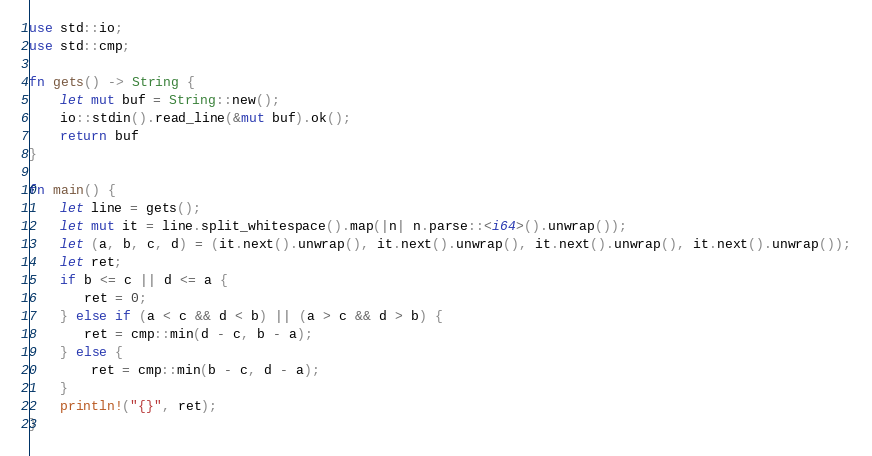<code> <loc_0><loc_0><loc_500><loc_500><_Rust_>use std::io;
use std::cmp;

fn gets() -> String {
    let mut buf = String::new();
    io::stdin().read_line(&mut buf).ok();
    return buf
}

fn main() {
    let line = gets();
    let mut it = line.split_whitespace().map(|n| n.parse::<i64>().unwrap());
    let (a, b, c, d) = (it.next().unwrap(), it.next().unwrap(), it.next().unwrap(), it.next().unwrap());
    let ret;
    if b <= c || d <= a {
       ret = 0;
    } else if (a < c && d < b) || (a > c && d > b) {
       ret = cmp::min(d - c, b - a);
    } else {
        ret = cmp::min(b - c, d - a);
    }
    println!("{}", ret);
}

</code> 